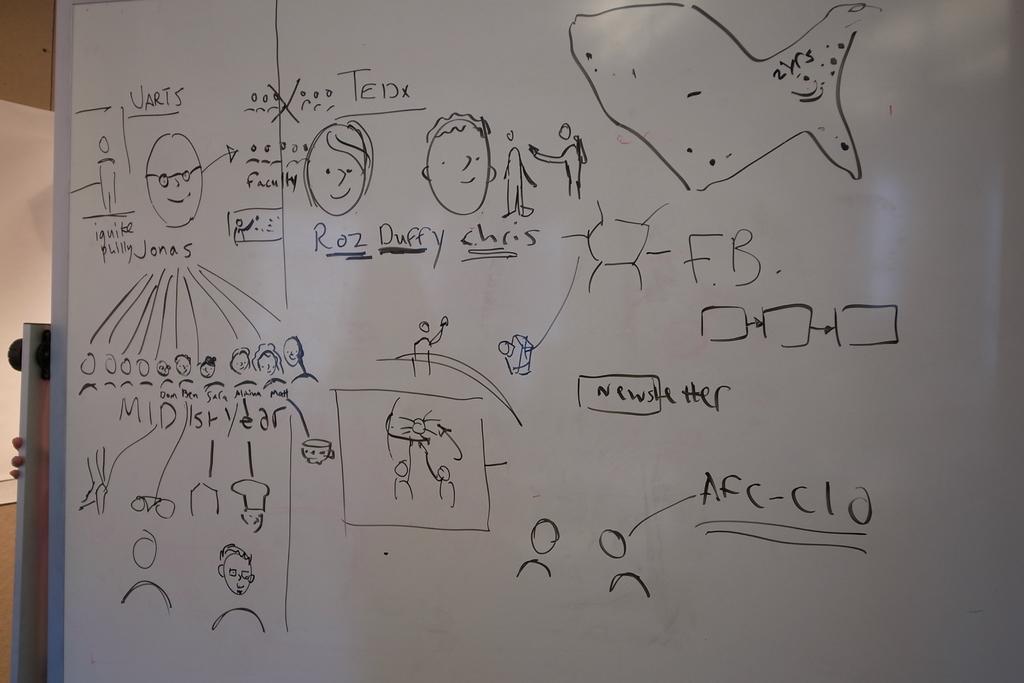How would you summarize this image in a sentence or two? In this image there are some drawings and words on the white board , and in the background there is a person holding a board. 